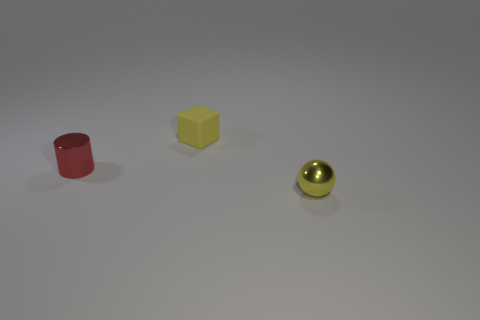Is the color of the tiny block the same as the metal sphere?
Offer a terse response. Yes. Is there anything else that is the same color as the tiny cylinder?
Your answer should be very brief. No. There is a thing right of the yellow cube; does it have the same color as the small block?
Your answer should be very brief. Yes. What number of things are matte spheres or small yellow objects?
Your response must be concise. 2. What is the shape of the small thing that is on the right side of the red metal cylinder and left of the yellow ball?
Your answer should be compact. Cube. What number of things are metal things to the left of the matte block or yellow things that are to the left of the metallic sphere?
Give a very brief answer. 2. There is a tiny matte thing; what shape is it?
Make the answer very short. Cube. What shape is the metallic thing that is the same color as the matte cube?
Offer a terse response. Sphere. What number of other objects have the same material as the small red object?
Make the answer very short. 1. What is the color of the shiny cylinder?
Give a very brief answer. Red. 